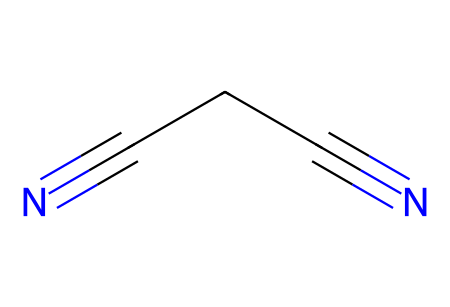What is the chemical name of the structure shown? The SMILES representation "N#CCC#N" indicates a chemical with two nitrile groups (-C≡N) connected by a carbon chain. This corresponds to the chemical name succinonitrile.
Answer: succinonitrile How many carbon atoms are present in succinonitrile? The SMILES "N#CCC#N" contains three carbon atoms in a linear arrangement (one between the two nitrogen atoms and the two terminal carbons).
Answer: 3 What type of functional groups are present in succinonitrile? The presence of "N#" in the SMILES indicates that there are nitrile functional groups (triple bond between carbon and nitrogen). Each N# represents a nitrile group in the compound.
Answer: nitrile What is the total number of nitrogen atoms in the structure? The SMILES "N#CCC#N" starts with "N#" and ends with another "N", indicating there are two nitrogen atoms present.
Answer: 2 What hybridization are the carbon atoms in succinonitrile? Each carbon atom is involved in a triple bond with a nitrogen atom, leading to sp hybridization for these carbons. Thus, each carbon in the nitrile groups is sp hybridized.
Answer: sp What kind of bond connects the nitrogen and carbon in succinonitrile? The bonds between the nitrogen and carbon in the structure are triple bonds, as indicated by the "N#" notation, which includes a triple bond (one sigma and two pi bonds).
Answer: triple bond 